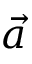<formula> <loc_0><loc_0><loc_500><loc_500>\vec { a }</formula> 